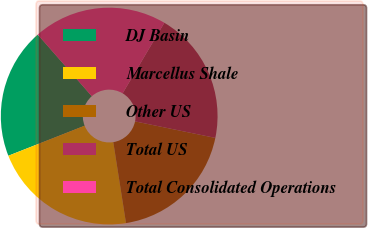<chart> <loc_0><loc_0><loc_500><loc_500><pie_chart><fcel>DJ Basin<fcel>Marcellus Shale<fcel>Other US<fcel>Total US<fcel>Total Consolidated Operations<nl><fcel>19.51%<fcel>21.51%<fcel>19.29%<fcel>19.73%<fcel>19.96%<nl></chart> 